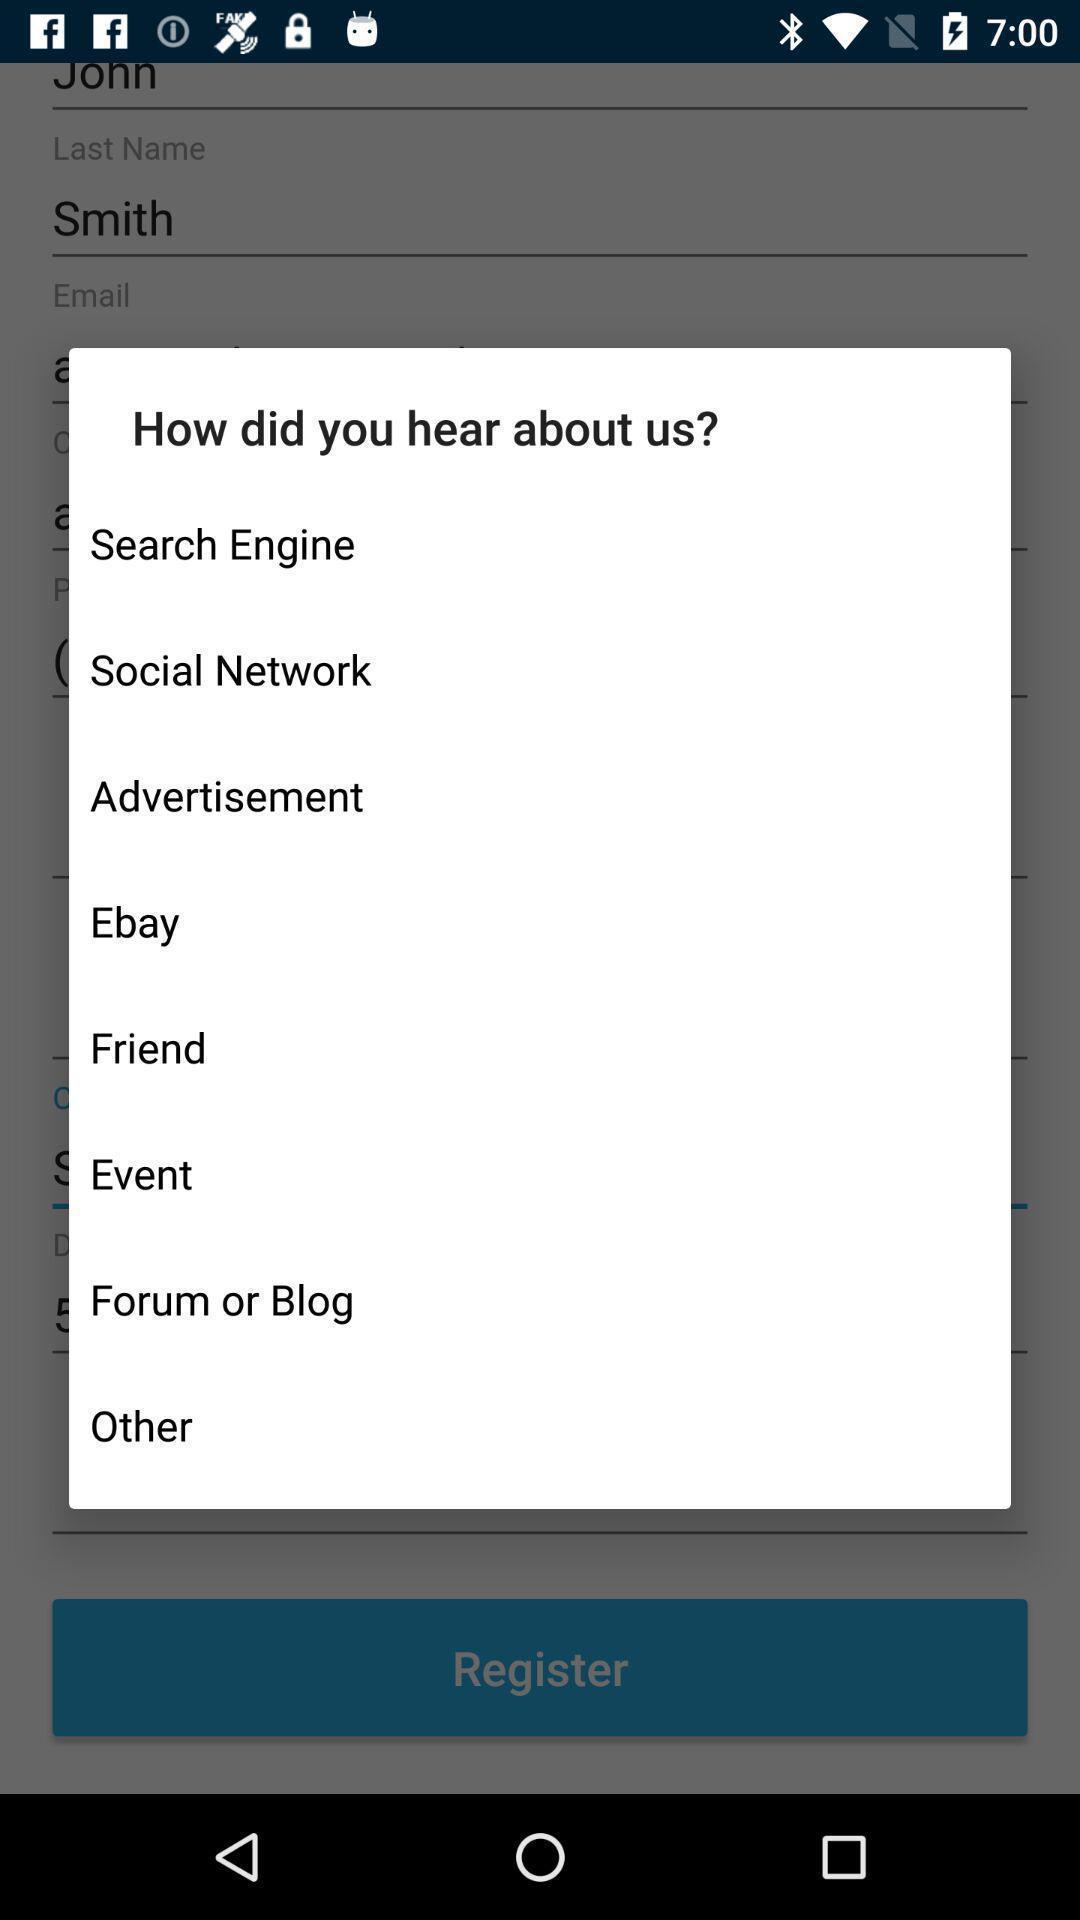Describe this image in words. Pop-up with options through which source you came to application. 